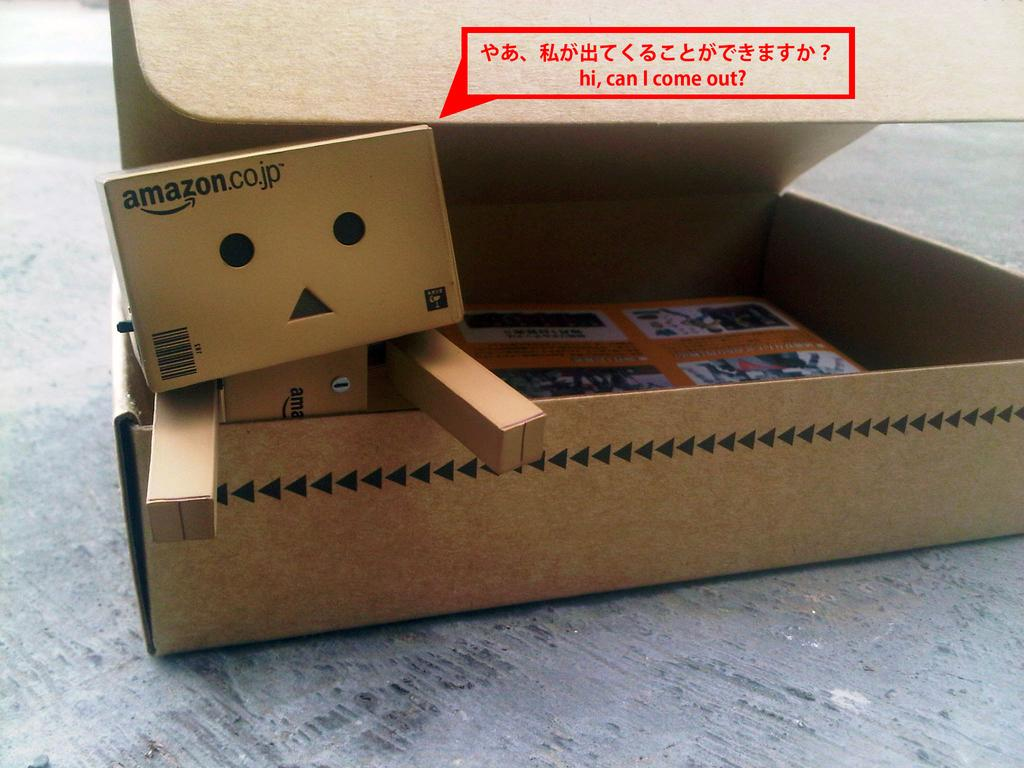Provide a one-sentence caption for the provided image. Cardboard boxes from Amazon are arranged to look like a person. 